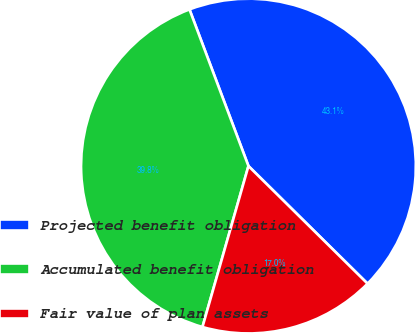<chart> <loc_0><loc_0><loc_500><loc_500><pie_chart><fcel>Projected benefit obligation<fcel>Accumulated benefit obligation<fcel>Fair value of plan assets<nl><fcel>43.13%<fcel>39.84%<fcel>17.03%<nl></chart> 